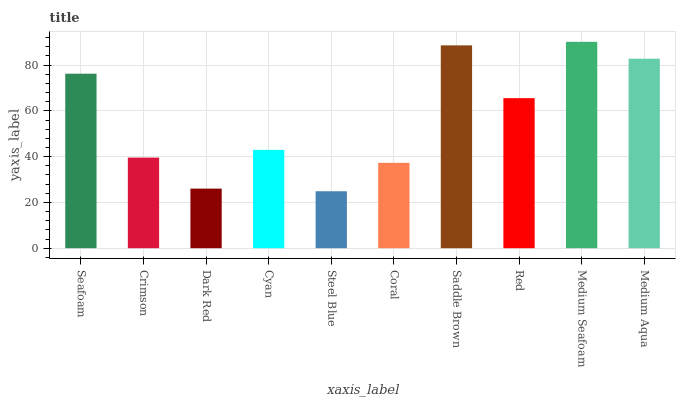Is Steel Blue the minimum?
Answer yes or no. Yes. Is Medium Seafoam the maximum?
Answer yes or no. Yes. Is Crimson the minimum?
Answer yes or no. No. Is Crimson the maximum?
Answer yes or no. No. Is Seafoam greater than Crimson?
Answer yes or no. Yes. Is Crimson less than Seafoam?
Answer yes or no. Yes. Is Crimson greater than Seafoam?
Answer yes or no. No. Is Seafoam less than Crimson?
Answer yes or no. No. Is Red the high median?
Answer yes or no. Yes. Is Cyan the low median?
Answer yes or no. Yes. Is Dark Red the high median?
Answer yes or no. No. Is Seafoam the low median?
Answer yes or no. No. 